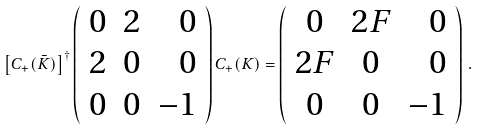<formula> <loc_0><loc_0><loc_500><loc_500>\left [ { C } _ { + } ( \bar { K } ) \right ] ^ { \dagger } \left ( \begin{array} { c c r } 0 & 2 & 0 \\ 2 & 0 & 0 \\ 0 & 0 & - 1 \end{array} \right ) { C } _ { + } ( K ) = \left ( \begin{array} { c c r } 0 & 2 F & 0 \\ 2 F & 0 & 0 \\ 0 & 0 & - 1 \end{array} \right ) \, .</formula> 